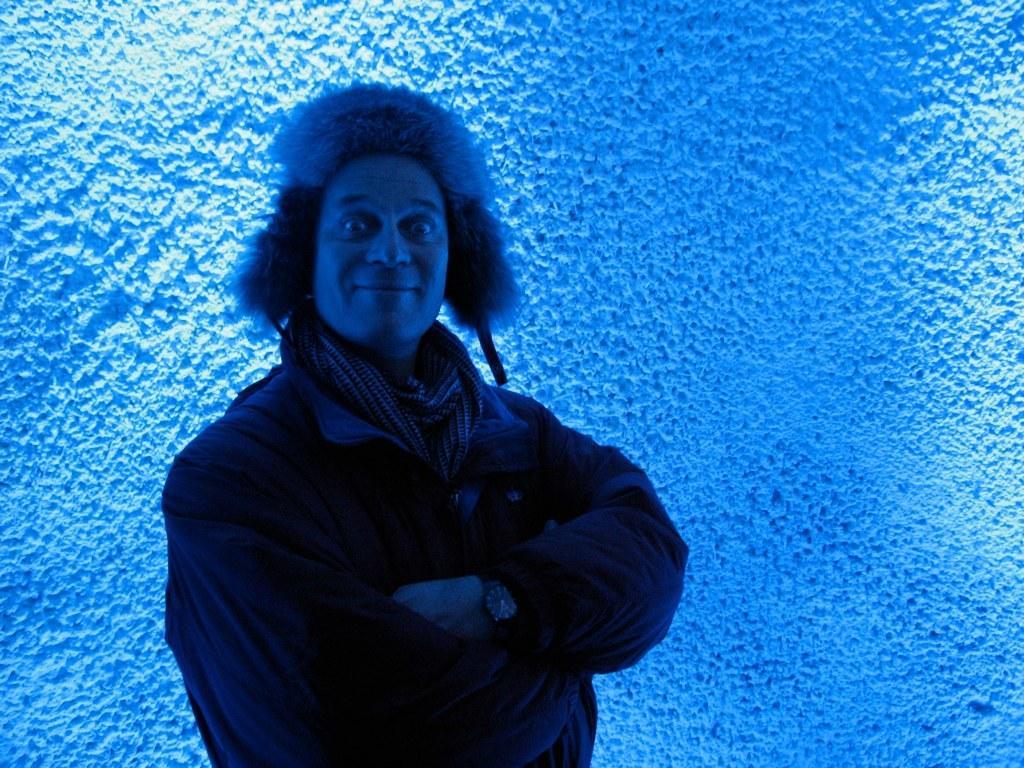Can you describe this image briefly? In this image, I can see the man standing and smiling. In the background, I think this is the wall. 